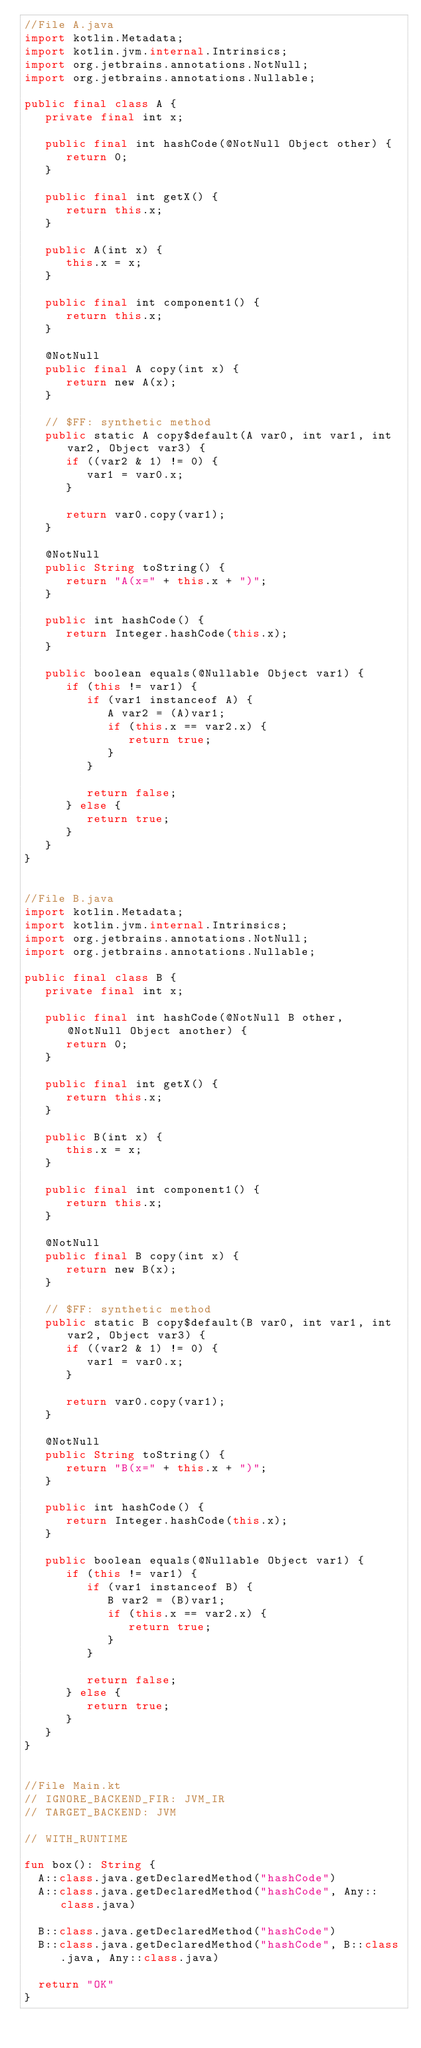<code> <loc_0><loc_0><loc_500><loc_500><_Kotlin_>//File A.java
import kotlin.Metadata;
import kotlin.jvm.internal.Intrinsics;
import org.jetbrains.annotations.NotNull;
import org.jetbrains.annotations.Nullable;

public final class A {
   private final int x;

   public final int hashCode(@NotNull Object other) {
      return 0;
   }

   public final int getX() {
      return this.x;
   }

   public A(int x) {
      this.x = x;
   }

   public final int component1() {
      return this.x;
   }

   @NotNull
   public final A copy(int x) {
      return new A(x);
   }

   // $FF: synthetic method
   public static A copy$default(A var0, int var1, int var2, Object var3) {
      if ((var2 & 1) != 0) {
         var1 = var0.x;
      }

      return var0.copy(var1);
   }

   @NotNull
   public String toString() {
      return "A(x=" + this.x + ")";
   }

   public int hashCode() {
      return Integer.hashCode(this.x);
   }

   public boolean equals(@Nullable Object var1) {
      if (this != var1) {
         if (var1 instanceof A) {
            A var2 = (A)var1;
            if (this.x == var2.x) {
               return true;
            }
         }

         return false;
      } else {
         return true;
      }
   }
}


//File B.java
import kotlin.Metadata;
import kotlin.jvm.internal.Intrinsics;
import org.jetbrains.annotations.NotNull;
import org.jetbrains.annotations.Nullable;

public final class B {
   private final int x;

   public final int hashCode(@NotNull B other, @NotNull Object another) {
      return 0;
   }

   public final int getX() {
      return this.x;
   }

   public B(int x) {
      this.x = x;
   }

   public final int component1() {
      return this.x;
   }

   @NotNull
   public final B copy(int x) {
      return new B(x);
   }

   // $FF: synthetic method
   public static B copy$default(B var0, int var1, int var2, Object var3) {
      if ((var2 & 1) != 0) {
         var1 = var0.x;
      }

      return var0.copy(var1);
   }

   @NotNull
   public String toString() {
      return "B(x=" + this.x + ")";
   }

   public int hashCode() {
      return Integer.hashCode(this.x);
   }

   public boolean equals(@Nullable Object var1) {
      if (this != var1) {
         if (var1 instanceof B) {
            B var2 = (B)var1;
            if (this.x == var2.x) {
               return true;
            }
         }

         return false;
      } else {
         return true;
      }
   }
}


//File Main.kt
// IGNORE_BACKEND_FIR: JVM_IR
// TARGET_BACKEND: JVM

// WITH_RUNTIME

fun box(): String {
  A::class.java.getDeclaredMethod("hashCode")
  A::class.java.getDeclaredMethod("hashCode", Any::class.java)

  B::class.java.getDeclaredMethod("hashCode")
  B::class.java.getDeclaredMethod("hashCode", B::class.java, Any::class.java)

  return "OK"
}

</code> 